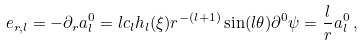<formula> <loc_0><loc_0><loc_500><loc_500>e _ { r , l } = - \partial _ { r } a _ { l } ^ { 0 } = l c _ { l } h _ { l } ( \xi ) r ^ { - ( l + 1 ) } \sin ( l \theta ) \partial ^ { 0 } \psi = \frac { l } { r } a _ { l } ^ { 0 } \, ,</formula> 